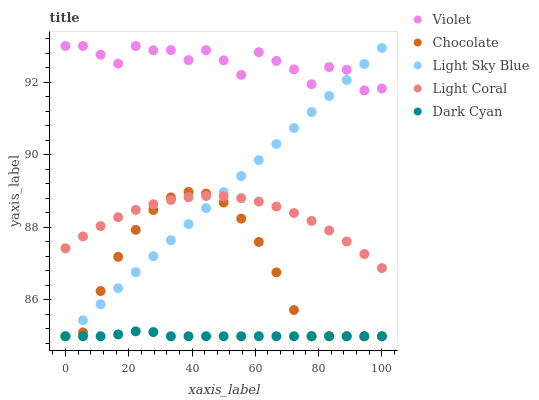Does Dark Cyan have the minimum area under the curve?
Answer yes or no. Yes. Does Violet have the maximum area under the curve?
Answer yes or no. Yes. Does Chocolate have the minimum area under the curve?
Answer yes or no. No. Does Chocolate have the maximum area under the curve?
Answer yes or no. No. Is Light Sky Blue the smoothest?
Answer yes or no. Yes. Is Violet the roughest?
Answer yes or no. Yes. Is Dark Cyan the smoothest?
Answer yes or no. No. Is Dark Cyan the roughest?
Answer yes or no. No. Does Dark Cyan have the lowest value?
Answer yes or no. Yes. Does Violet have the lowest value?
Answer yes or no. No. Does Violet have the highest value?
Answer yes or no. Yes. Does Chocolate have the highest value?
Answer yes or no. No. Is Light Coral less than Violet?
Answer yes or no. Yes. Is Violet greater than Light Coral?
Answer yes or no. Yes. Does Chocolate intersect Light Sky Blue?
Answer yes or no. Yes. Is Chocolate less than Light Sky Blue?
Answer yes or no. No. Is Chocolate greater than Light Sky Blue?
Answer yes or no. No. Does Light Coral intersect Violet?
Answer yes or no. No. 